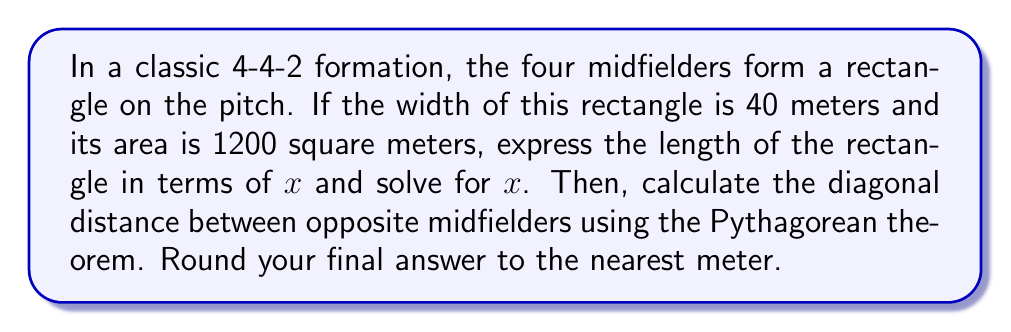Show me your answer to this math problem. 1) Let's express the length of the rectangle in terms of $x$ meters.

2) The area of a rectangle is given by length × width. We know:
   Area = 1200 m²
   Width = 40 m
   
   So, $1200 = 40x$

3) Solving for $x$:
   $$x = \frac{1200}{40} = 30$$

4) Therefore, the length of the rectangle is 30 meters.

5) To find the diagonal distance, we use the Pythagorean theorem:
   $$d^2 = 40^2 + 30^2$$

6) Simplifying:
   $$d^2 = 1600 + 900 = 2500$$

7) Taking the square root:
   $$d = \sqrt{2500} = 50$$

8) The diagonal distance is exactly 50 meters, so no rounding is necessary.

[asy]
unitsize(2mm);
draw((0,0)--(40,0)--(40,30)--(0,30)--cycle);
draw((0,0)--(40,30),dashed);
label("40 m", (20,0), S);
label("30 m", (40,15), E);
label("50 m", (20,15), NW);
[/asy]
Answer: 50 meters 